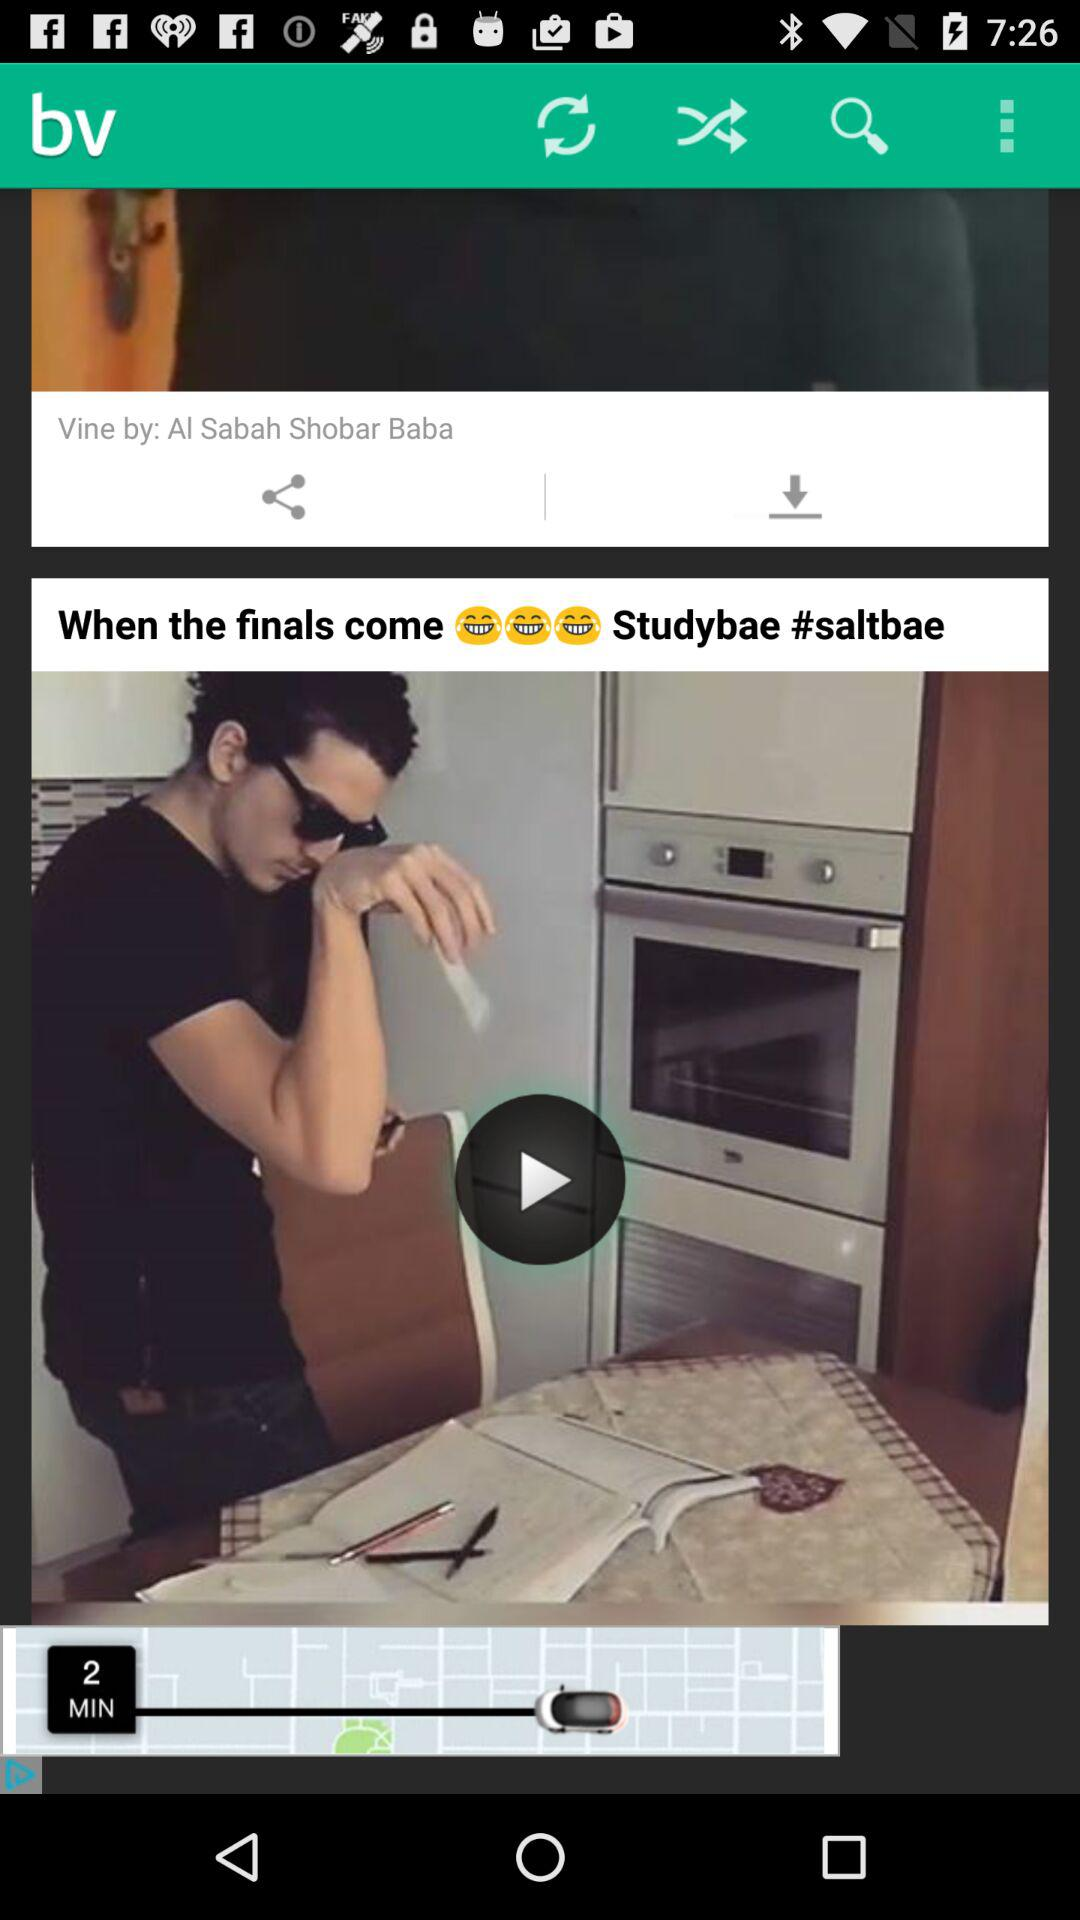What is the application Name? The application name is "bv". 